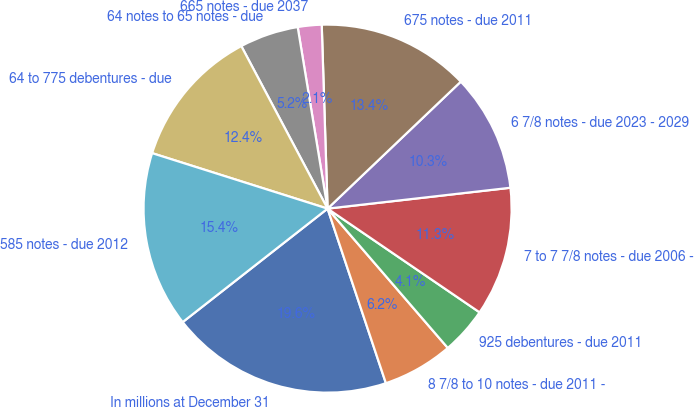<chart> <loc_0><loc_0><loc_500><loc_500><pie_chart><fcel>In millions at December 31<fcel>8 7/8 to 10 notes - due 2011 -<fcel>925 debentures - due 2011<fcel>7 to 7 7/8 notes - due 2006 -<fcel>6 7/8 notes - due 2023 - 2029<fcel>675 notes - due 2011<fcel>665 notes - due 2037<fcel>64 notes to 65 notes - due<fcel>64 to 775 debentures - due<fcel>585 notes - due 2012<nl><fcel>19.56%<fcel>6.2%<fcel>4.14%<fcel>11.34%<fcel>10.31%<fcel>13.39%<fcel>2.09%<fcel>5.17%<fcel>12.36%<fcel>15.45%<nl></chart> 